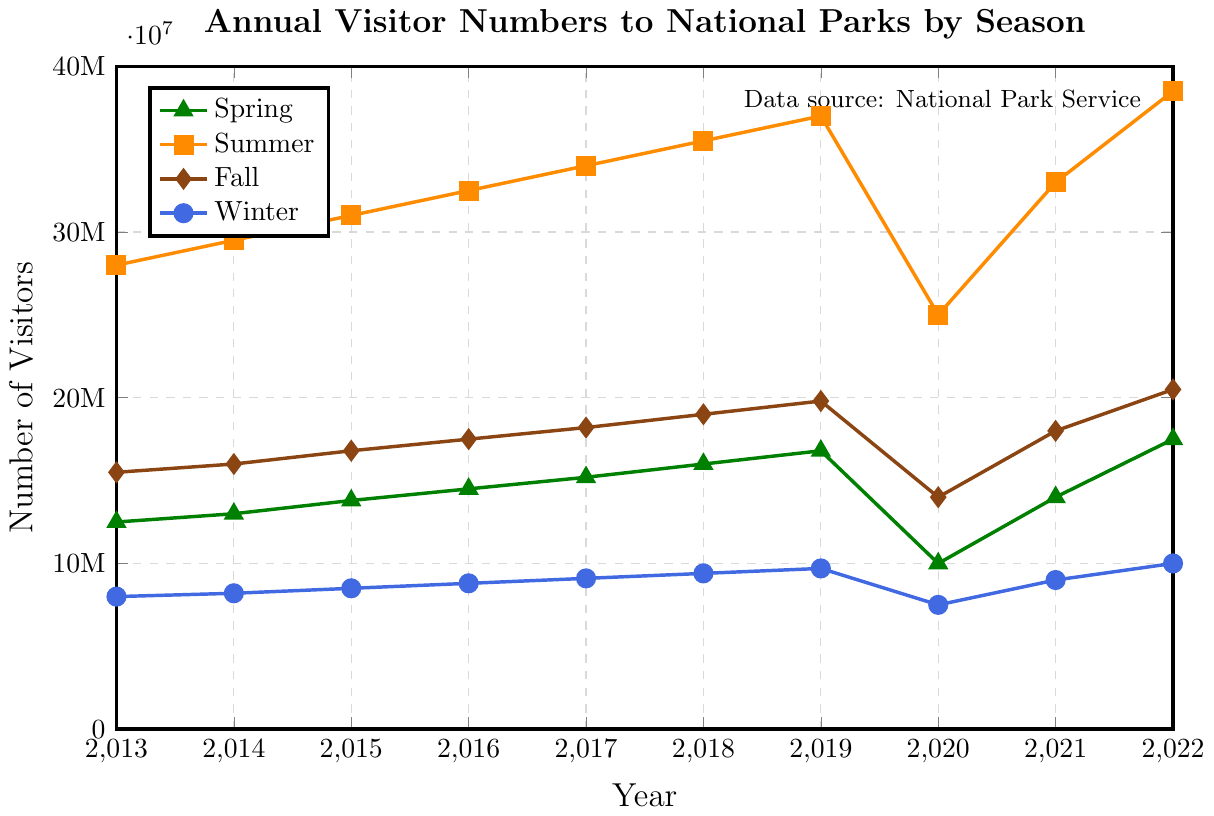What is the trend of visitor numbers in Winter from 2013 to 2022? Looking at the Winter line which is colored in blue, we observe that it generally trends upwards with a slight dip in 2020. The numbers rise from 8 million in 2013 to 10 million in 2022, with the lowest being in 2020 at 7.5 million.
Answer: Increasing with a dip in 2020 Which season had the highest number of visitors in 2022? Observing the year 2022 on the x-axis, the Summer line, which is colored orange, reaches the highest point among all seasons at 38.5 million visitors.
Answer: Summer What is the difference in the number of visitors between Summer and Winter in 2019? In 2019, Summer had 37 million visitors and Winter had 9.7 million visitors. Subtracting Winter's visitors from Summer's visitors: (37,000,000 - 9,700,000)
Answer: 27.3 million Which year saw the highest increase in Fall visitor numbers compared to the previous year? Comparing each year with the previous one for the Fall season (colored brown): 
2013-2014: 1 million 
2014-2015: 0.8 million 
2015-2016: 0.7 million 
2016-2017: 0.7 million 
2017-2018: 0.8 million 
2018-2019: 0.8 million 
2019-2020: -5.8 million (decrease)
2020-2021: 4 million 
2021-2022: 2.5 million 
The highest increase is between 2020 and 2021 with an increase of 4 million.
Answer: 2020-2021 What is the average number of Spring visitors over the decade? First, sum the Spring visitor numbers from 2013 to 2022: (12,500,000 + 13,000,000 + 13,800,000 + 14,500,000 + 15,200,000 + 16,000,000 + 16,800,000 + 10,000,000 + 14,000,000 + 17,500,000) = 143,300,000. Then divide by the number of years (10): 143,300,000 / 10
Answer: 14.33 million Which season shows the least fluctuation in visitor numbers over the decade? Assessing the vertical span (range) for each season's line: 
Spring ranges from 10 million to 17.5 million.
Summer ranges from 25 million to 38.5 million.
Fall ranges from 14 million to 20.5 million.
Winter ranges from 7.5 million to 10 million.
Winter, with a range of 2.5 million, shows the least fluctuation.
Answer: Winter By how much did the number of Spring visitors drop from 2019 to 2020? Spring visitors in 2019 were 16.8 million, and in 2020 they were 10 million. The drop is 16,800,000 - 10,000,000
Answer: 6.8 million Which two consecutive years saw the largest increase in visitor numbers for Summer? Comparing the increase between consecutive years for Summer:
2013 to 2014: 1.5 million
2014 to 2015: 1.5 million
2015 to 2016: 1.5 million
2016 to 2017: 1.5 million
2017 to 2018: 1.5 million
2018 to 2019: 1.5 million
2019 to 2020: -12 million (decrease)
2020 to 2021: 8 million
2021 to 2022: 5.5 million
The largest increase is 8 million between 2020 and 2021.
Answer: 2020-2021 What color represents the Spring season in the chart? Looking at the legend, the Spring season is represented by the line in green.
Answer: Green 